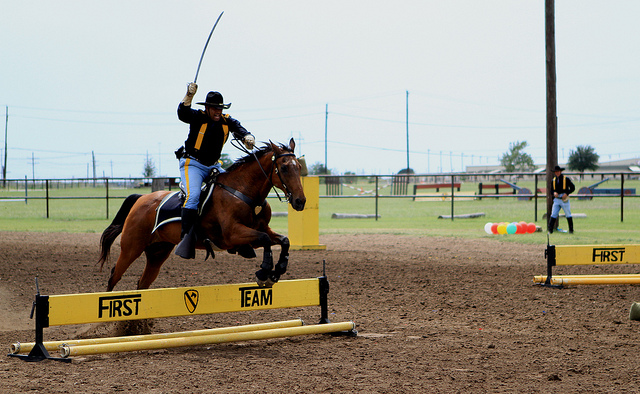Identify the text contained in this image. FIRST TEAM FIRST 